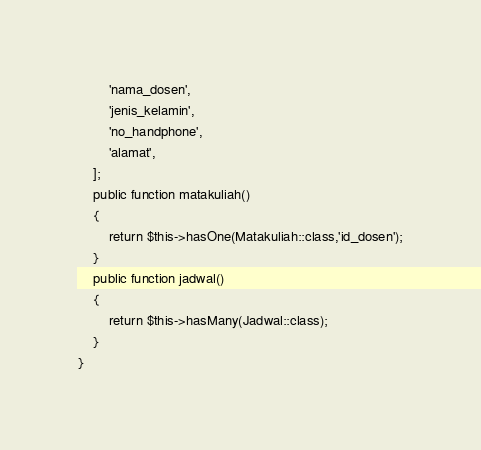<code> <loc_0><loc_0><loc_500><loc_500><_PHP_>        'nama_dosen',
        'jenis_kelamin',
        'no_handphone',
        'alamat',
    ];
    public function matakuliah()
    {
        return $this->hasOne(Matakuliah::class,'id_dosen');
    }
    public function jadwal()
    {
        return $this->hasMany(Jadwal::class);
    }
}
</code> 